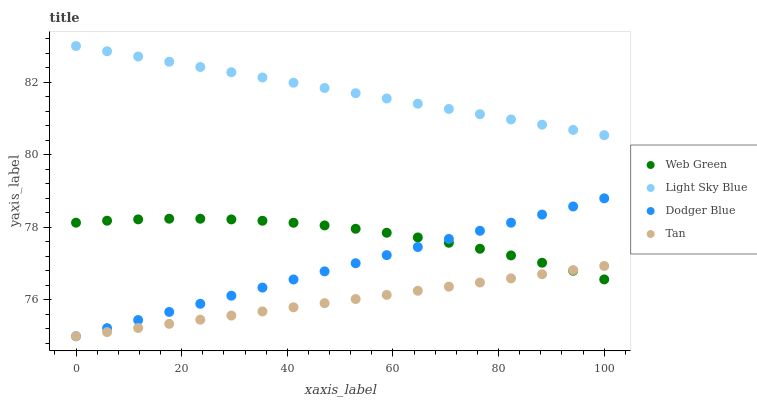Does Tan have the minimum area under the curve?
Answer yes or no. Yes. Does Light Sky Blue have the maximum area under the curve?
Answer yes or no. Yes. Does Dodger Blue have the minimum area under the curve?
Answer yes or no. No. Does Dodger Blue have the maximum area under the curve?
Answer yes or no. No. Is Tan the smoothest?
Answer yes or no. Yes. Is Web Green the roughest?
Answer yes or no. Yes. Is Light Sky Blue the smoothest?
Answer yes or no. No. Is Light Sky Blue the roughest?
Answer yes or no. No. Does Tan have the lowest value?
Answer yes or no. Yes. Does Light Sky Blue have the lowest value?
Answer yes or no. No. Does Light Sky Blue have the highest value?
Answer yes or no. Yes. Does Dodger Blue have the highest value?
Answer yes or no. No. Is Dodger Blue less than Light Sky Blue?
Answer yes or no. Yes. Is Light Sky Blue greater than Web Green?
Answer yes or no. Yes. Does Tan intersect Dodger Blue?
Answer yes or no. Yes. Is Tan less than Dodger Blue?
Answer yes or no. No. Is Tan greater than Dodger Blue?
Answer yes or no. No. Does Dodger Blue intersect Light Sky Blue?
Answer yes or no. No. 